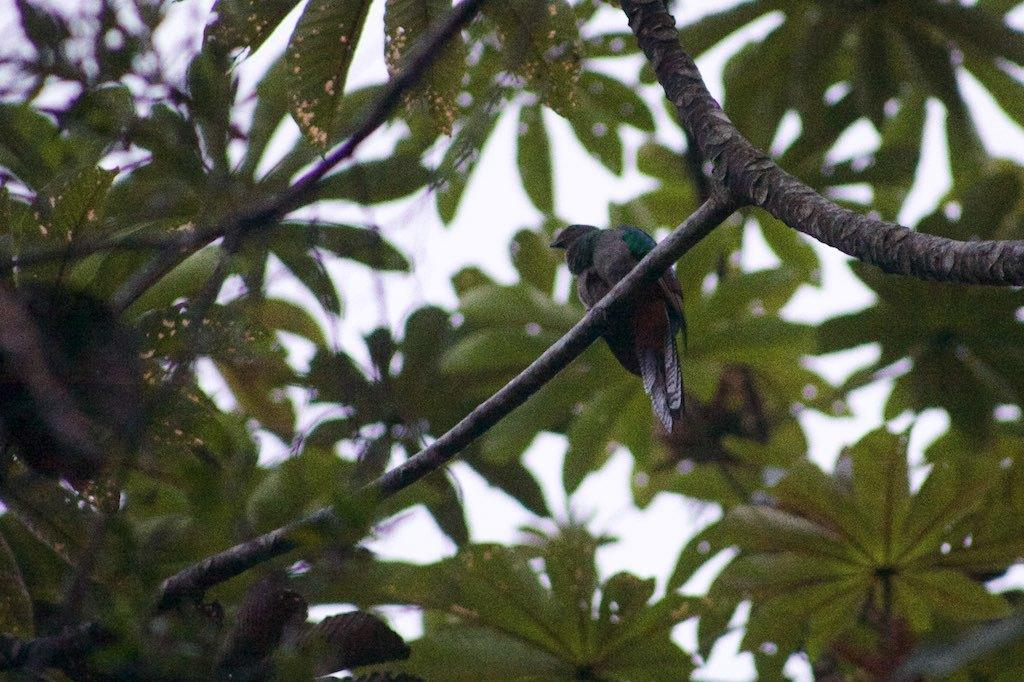What type of animal can be seen in the image? There is a bird in the image. Where is the bird located in the image? The bird is sitting on the branch of a tree. What type of brush is the bird using to paint in the image? There is no brush or painting activity present in the image; it features a bird sitting on a tree branch. 